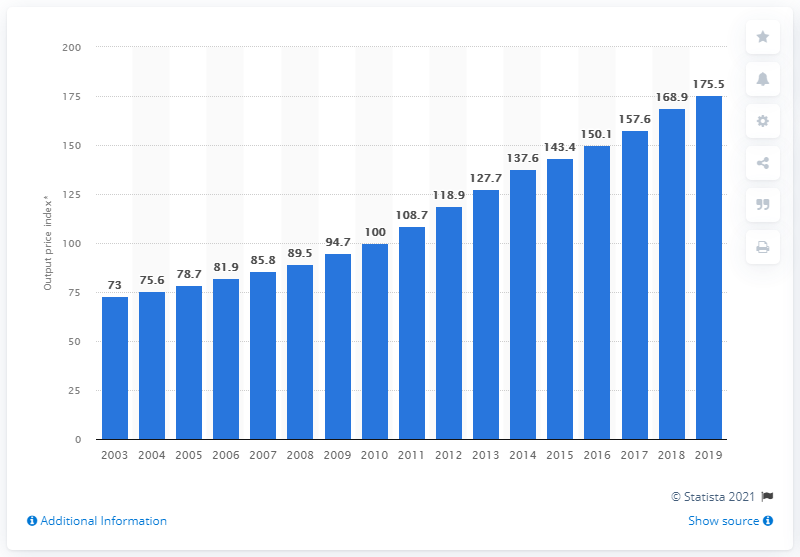Outline some significant characteristics in this image. In 2019, the average output price index of tobacco products sold by manufacturers in the UK was 175.5. 